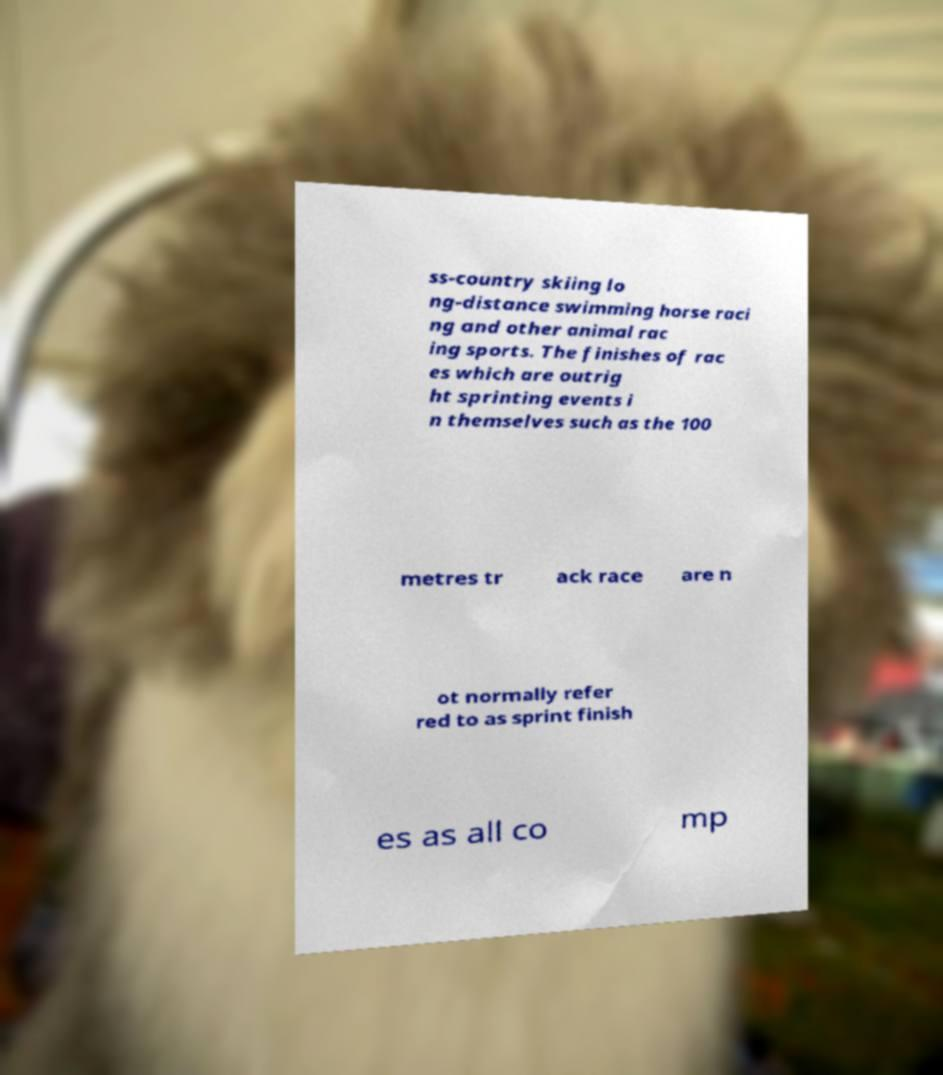There's text embedded in this image that I need extracted. Can you transcribe it verbatim? ss-country skiing lo ng-distance swimming horse raci ng and other animal rac ing sports. The finishes of rac es which are outrig ht sprinting events i n themselves such as the 100 metres tr ack race are n ot normally refer red to as sprint finish es as all co mp 